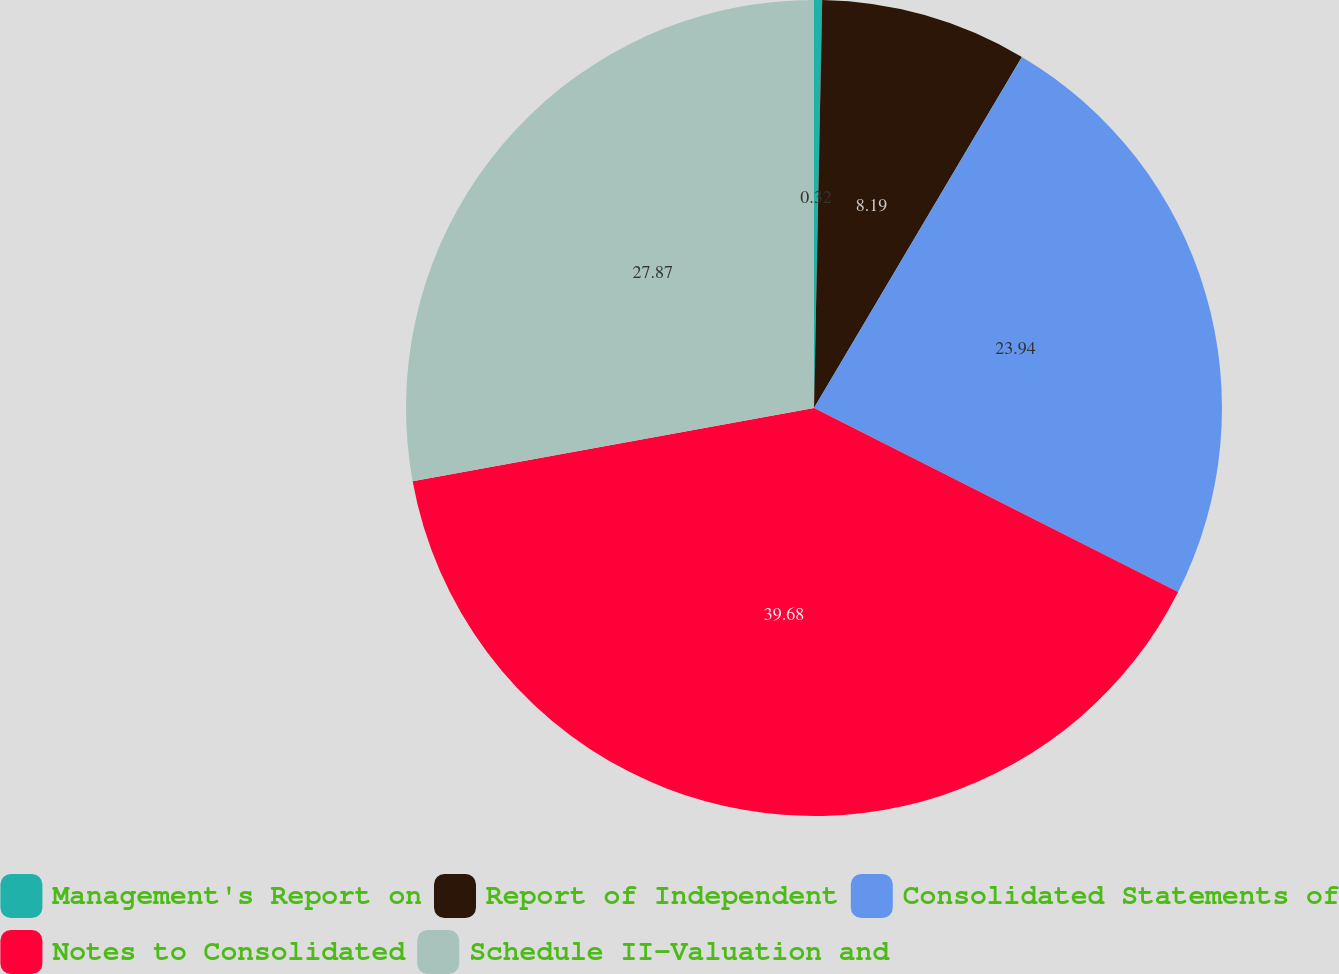Convert chart to OTSL. <chart><loc_0><loc_0><loc_500><loc_500><pie_chart><fcel>Management's Report on<fcel>Report of Independent<fcel>Consolidated Statements of<fcel>Notes to Consolidated<fcel>Schedule II-Valuation and<nl><fcel>0.32%<fcel>8.19%<fcel>23.94%<fcel>39.68%<fcel>27.87%<nl></chart> 